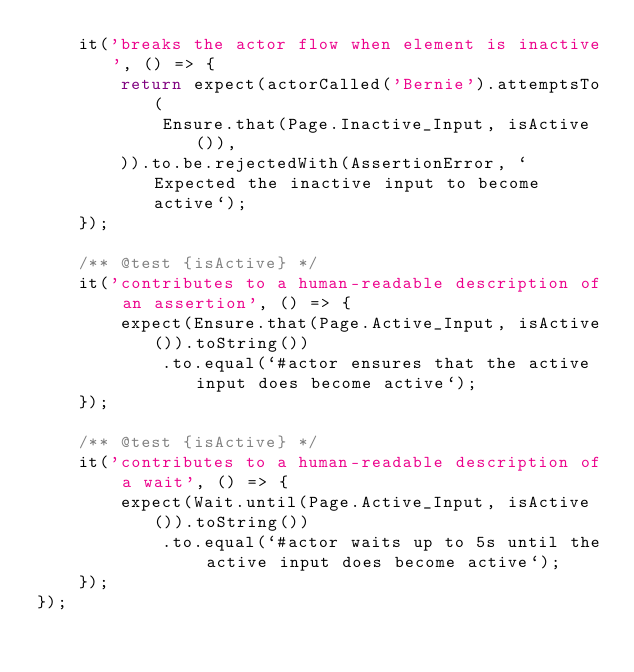<code> <loc_0><loc_0><loc_500><loc_500><_TypeScript_>    it('breaks the actor flow when element is inactive', () => {
        return expect(actorCalled('Bernie').attemptsTo(
            Ensure.that(Page.Inactive_Input, isActive()),
        )).to.be.rejectedWith(AssertionError, `Expected the inactive input to become active`);
    });

    /** @test {isActive} */
    it('contributes to a human-readable description of an assertion', () => {
        expect(Ensure.that(Page.Active_Input, isActive()).toString())
            .to.equal(`#actor ensures that the active input does become active`);
    });

    /** @test {isActive} */
    it('contributes to a human-readable description of a wait', () => {
        expect(Wait.until(Page.Active_Input, isActive()).toString())
            .to.equal(`#actor waits up to 5s until the active input does become active`);
    });
});
</code> 